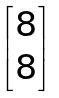<formula> <loc_0><loc_0><loc_500><loc_500>\begin{bmatrix} 8 \\ 8 \end{bmatrix}</formula> 